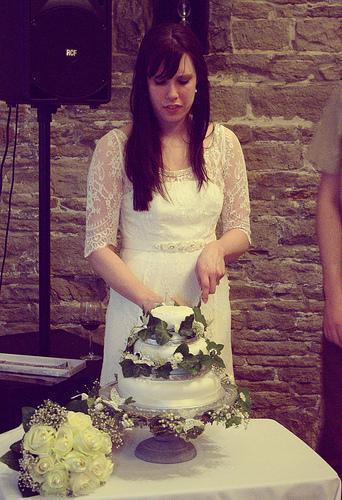How many cakes are there?
Give a very brief answer. 1. 